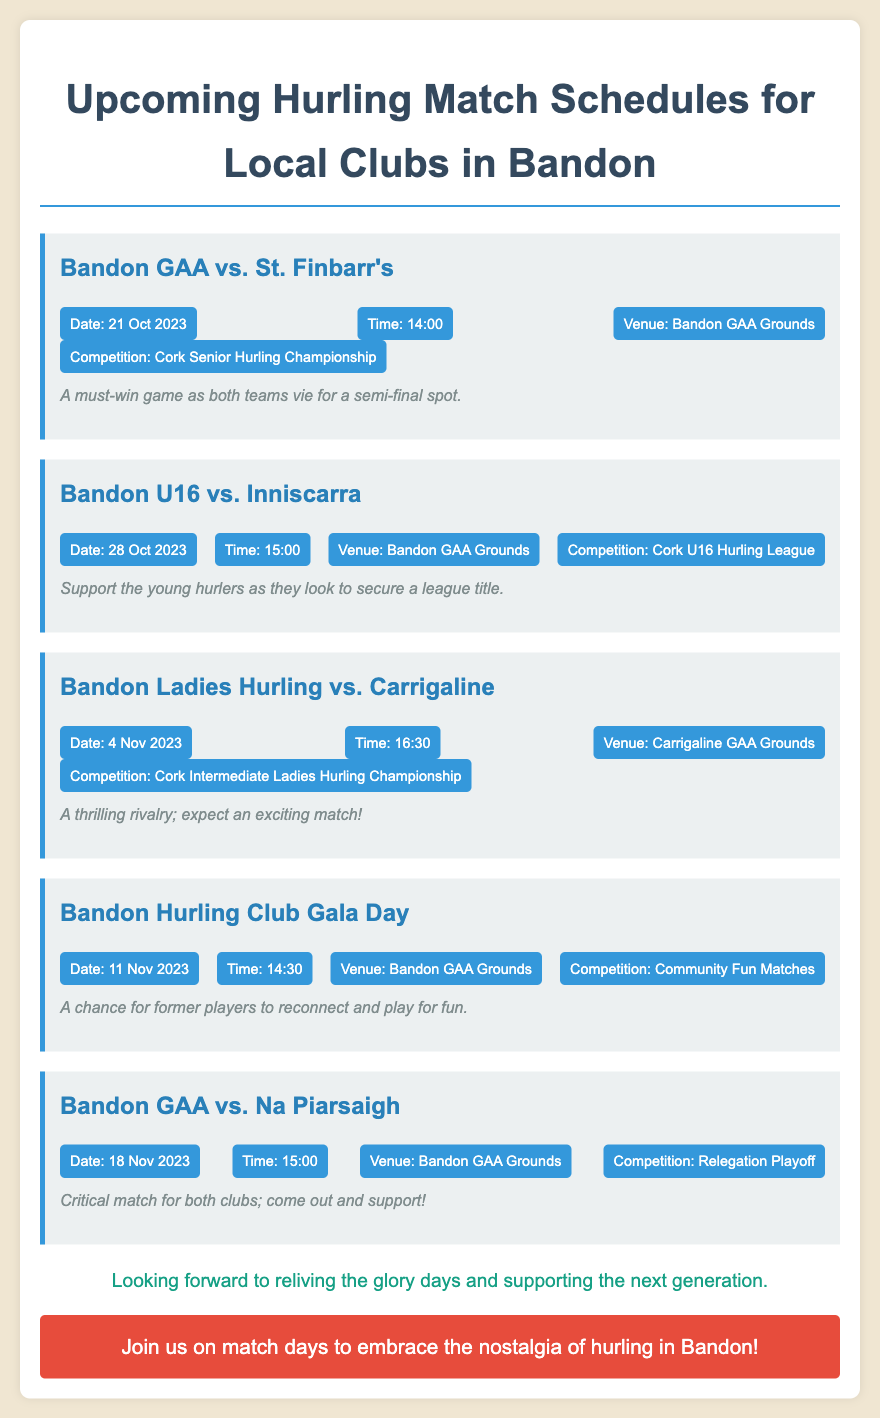What is the date of the match between Bandon GAA and St. Finbarr's? The date is specifically mentioned in the document as 21 Oct 2023.
Answer: 21 Oct 2023 What is the venue for the Bandon U16 match against Inniscarra? The document states that the venue for this match is Bandon GAA Grounds.
Answer: Bandon GAA Grounds What time does the Bandon Ladies Hurling match start? The time for this match is listed as 16:30 in the document.
Answer: 16:30 Which competition is Bandon GAA playing in when they face Na Piarsaigh? The competition is referred to as the Relegation Playoff in the document.
Answer: Relegation Playoff What is the purpose of the Bandon Hurling Club Gala Day? The document notes it as a chance for former players to reconnect and play for fun.
Answer: Reconnect and play for fun Which team is playing against Bandon GAA on 18 Nov 2023? The opponent team for that date is Na Piarsaigh as mentioned in the document.
Answer: Na Piarsaigh How many matches are scheduled at the Bandon GAA Grounds? The document lists four matches scheduled at this location.
Answer: Four matches What is the emotion conveyed in the reflection section of the document? The reflection expresses a sense of nostalgia for past experiences in hurling.
Answer: Nostalgia Which age group is the Bandon U16 match targeting? The match is specifically for the U16 age group, as indicated in the document.
Answer: U16 